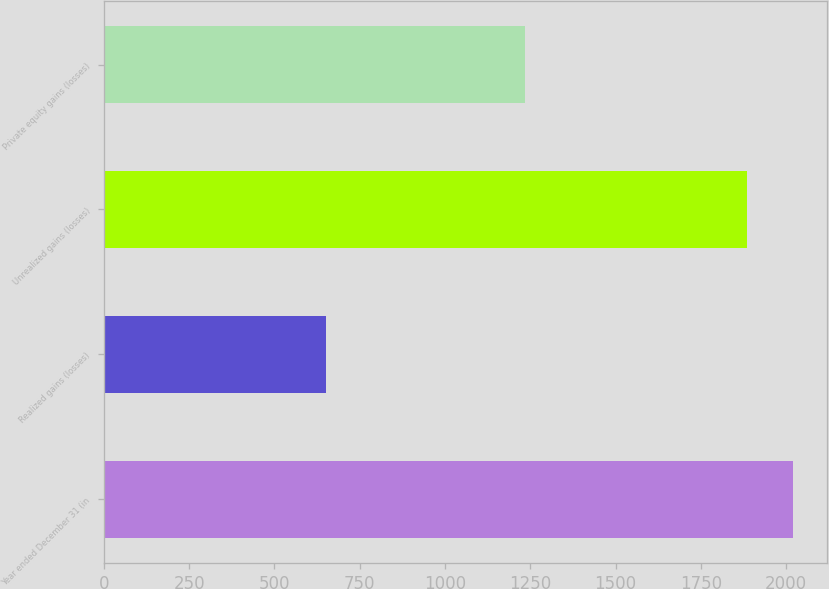Convert chart to OTSL. <chart><loc_0><loc_0><loc_500><loc_500><bar_chart><fcel>Year ended December 31 (in<fcel>Realized gains (losses)<fcel>Unrealized gains (losses)<fcel>Private equity gains (losses)<nl><fcel>2019<fcel>651<fcel>1884<fcel>1233<nl></chart> 